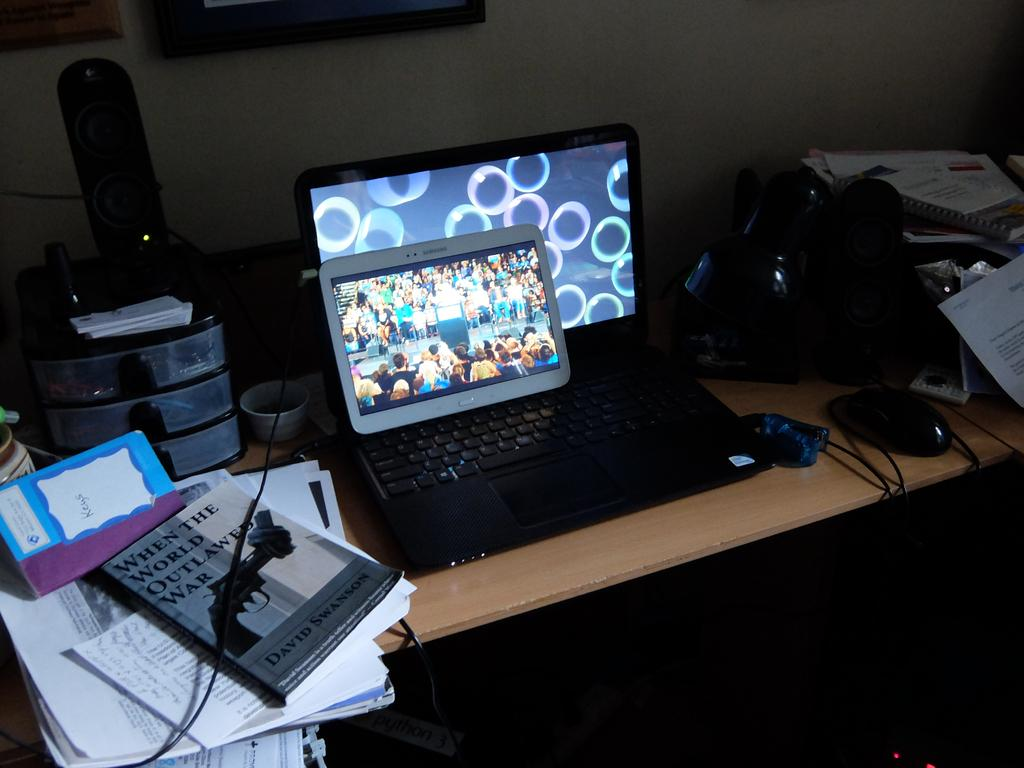Provide a one-sentence caption for the provided image. A laptop and tablet on a table next to the book When the World Outlawed War. 